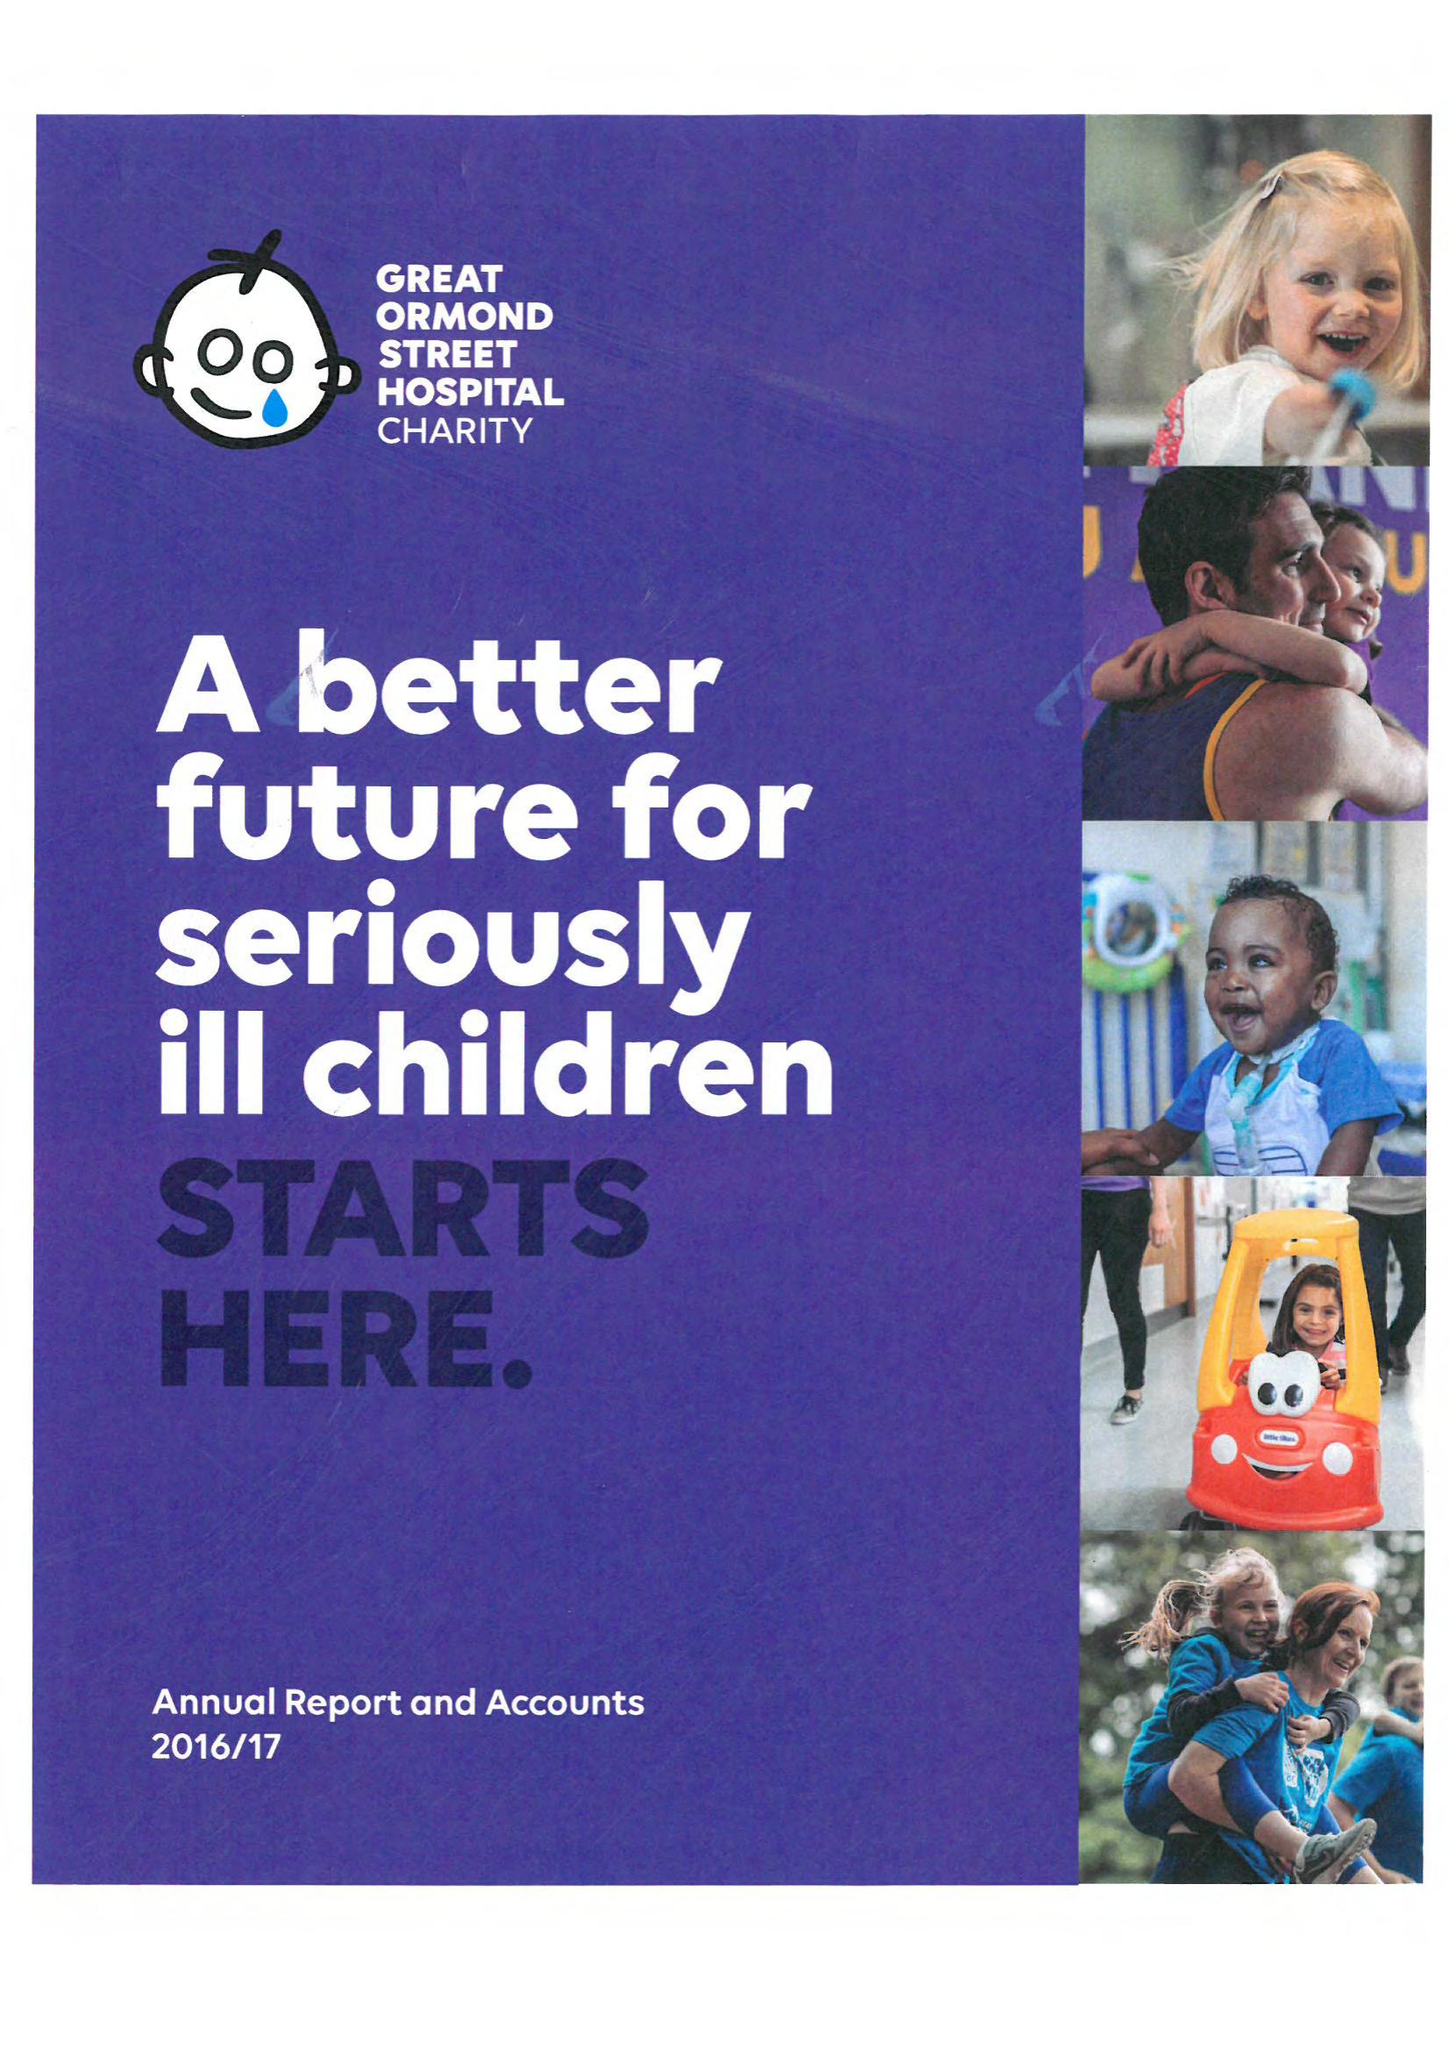What is the value for the address__postcode?
Answer the question using a single word or phrase. WC1N 1LE 